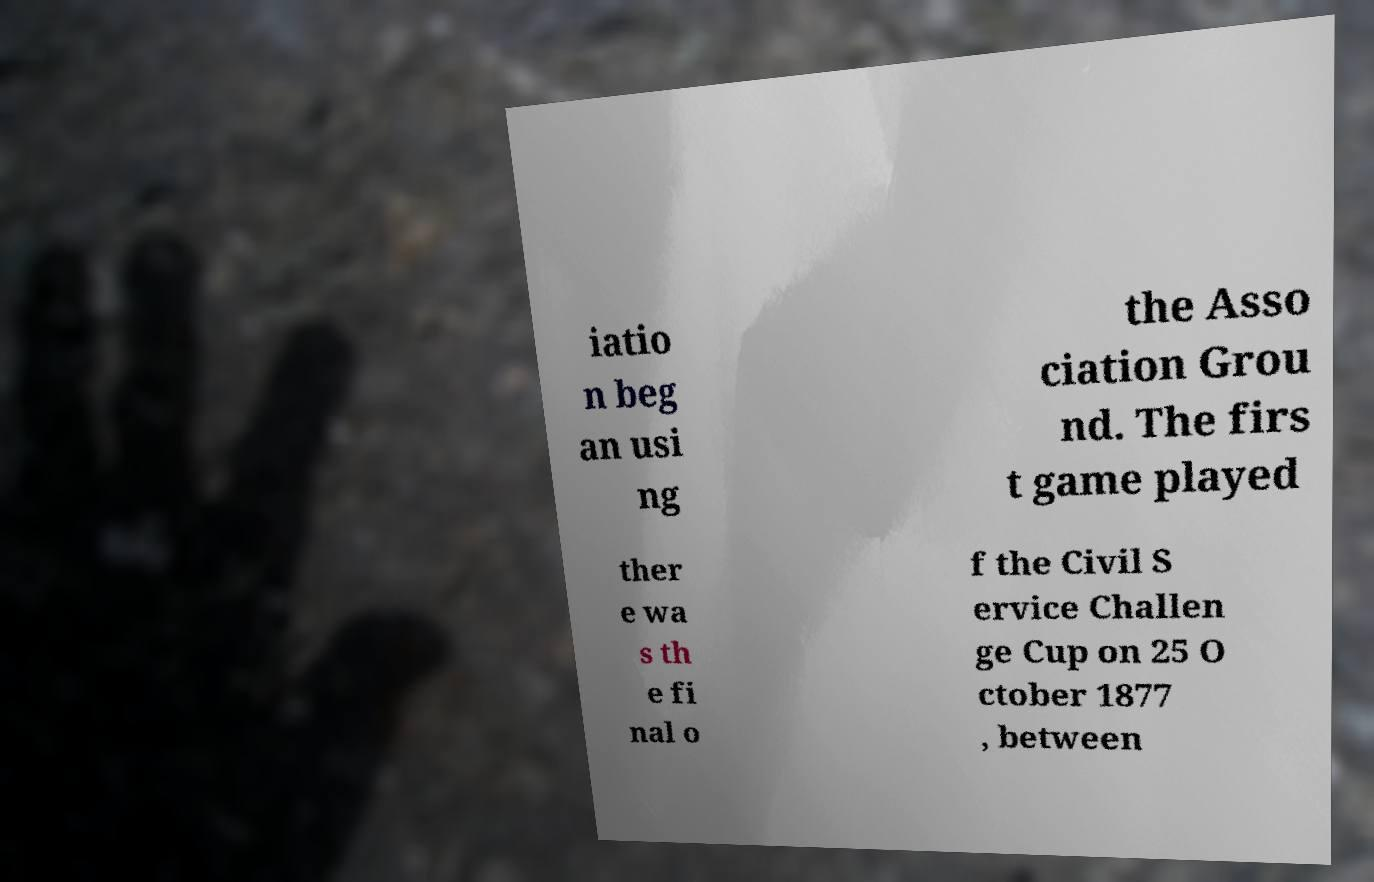Could you assist in decoding the text presented in this image and type it out clearly? iatio n beg an usi ng the Asso ciation Grou nd. The firs t game played ther e wa s th e fi nal o f the Civil S ervice Challen ge Cup on 25 O ctober 1877 , between 